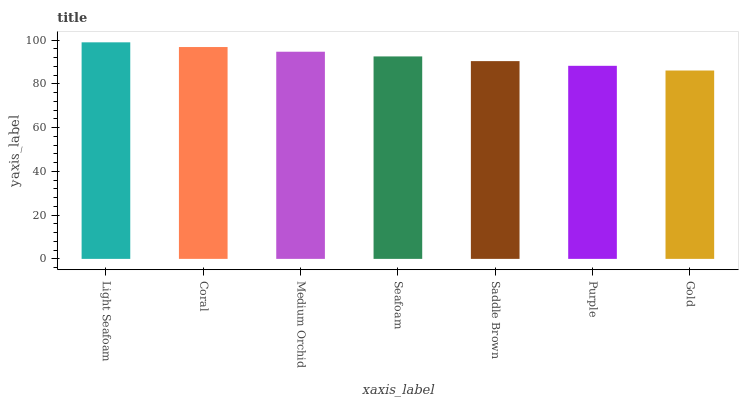Is Gold the minimum?
Answer yes or no. Yes. Is Light Seafoam the maximum?
Answer yes or no. Yes. Is Coral the minimum?
Answer yes or no. No. Is Coral the maximum?
Answer yes or no. No. Is Light Seafoam greater than Coral?
Answer yes or no. Yes. Is Coral less than Light Seafoam?
Answer yes or no. Yes. Is Coral greater than Light Seafoam?
Answer yes or no. No. Is Light Seafoam less than Coral?
Answer yes or no. No. Is Seafoam the high median?
Answer yes or no. Yes. Is Seafoam the low median?
Answer yes or no. Yes. Is Gold the high median?
Answer yes or no. No. Is Saddle Brown the low median?
Answer yes or no. No. 